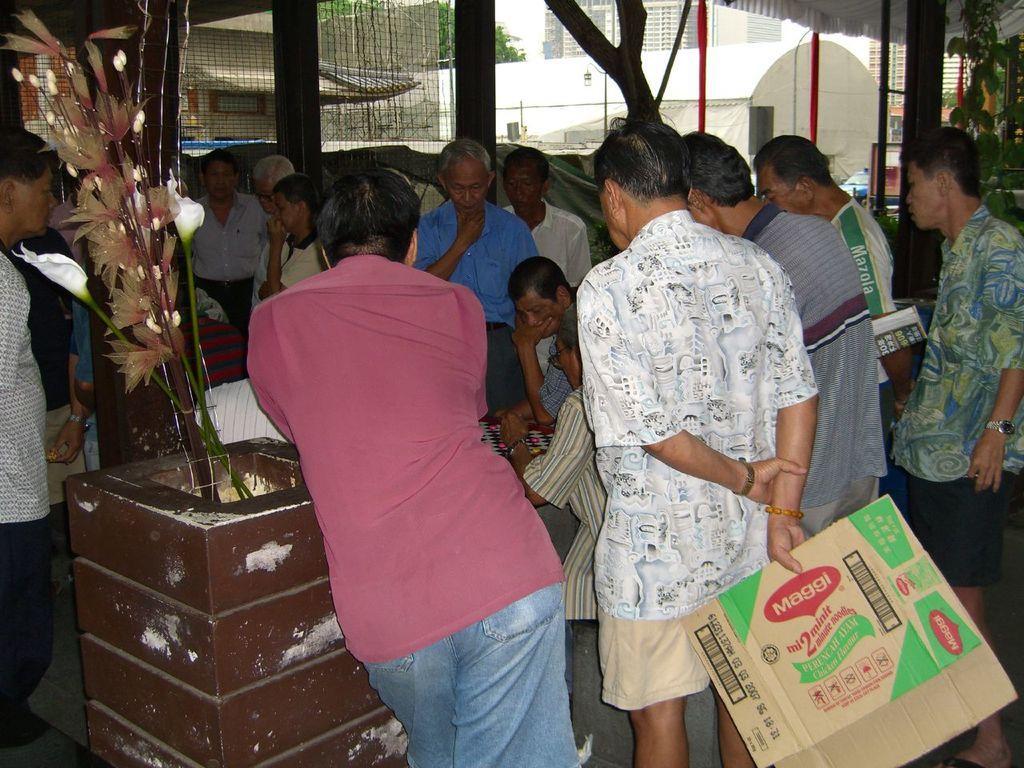How would you summarize this image in a sentence or two? In this picture there is a man who is standing near to the concrete wall. On that I can see some plants. On the left I can see many people were standing near to the table. On the table I can see people were playing the chess. In the background I can see the trees, sky, buildings, wall, street lights and other objects. 